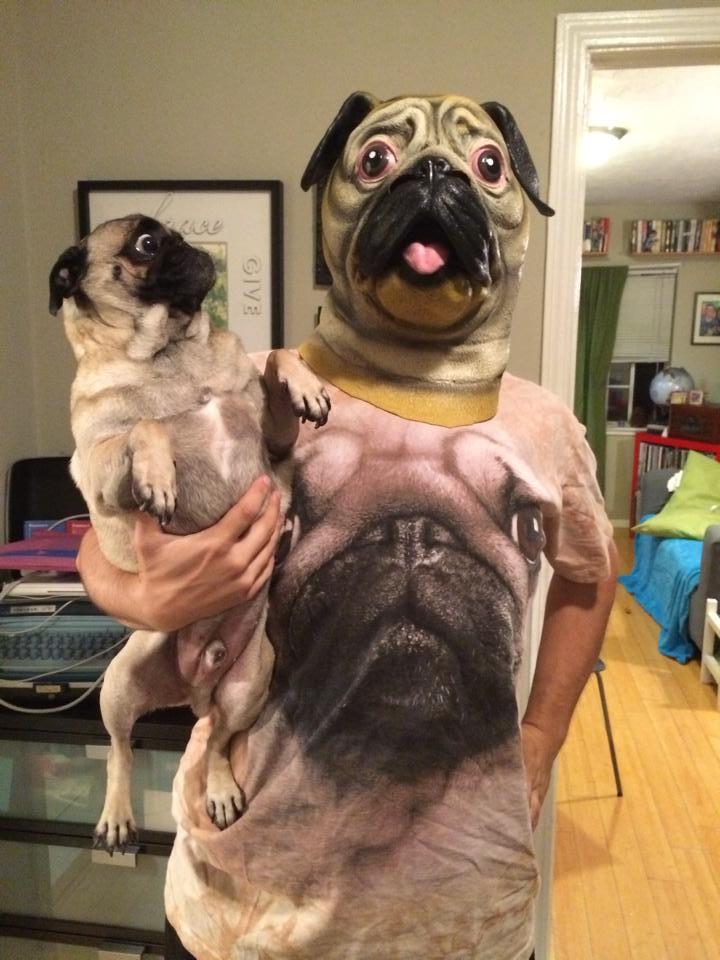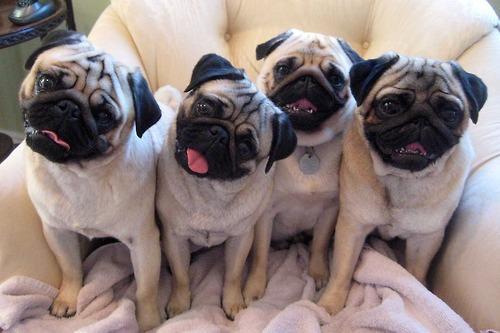The first image is the image on the left, the second image is the image on the right. Given the left and right images, does the statement "There are two puppies total." hold true? Answer yes or no. No. The first image is the image on the left, the second image is the image on the right. Evaluate the accuracy of this statement regarding the images: "There are two puppies". Is it true? Answer yes or no. No. 